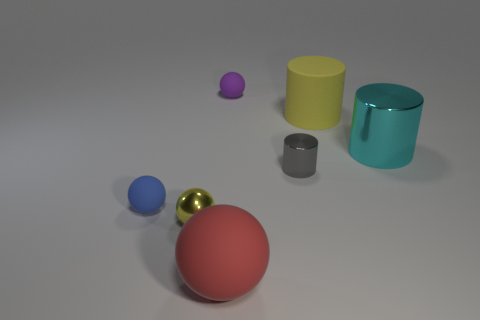What size is the sphere that is to the right of the small yellow shiny ball and in front of the blue object?
Your response must be concise. Large. The large matte thing that is the same shape as the small blue object is what color?
Your response must be concise. Red. Is the number of yellow metallic spheres on the left side of the small yellow thing greater than the number of large yellow rubber things in front of the large cyan metallic cylinder?
Your response must be concise. No. What number of other things are there of the same shape as the small blue object?
Your answer should be compact. 3. Is there a gray metallic cylinder on the left side of the yellow thing behind the tiny blue matte ball?
Provide a succinct answer. Yes. What number of things are there?
Make the answer very short. 7. There is a big shiny cylinder; does it have the same color as the rubber sphere that is to the left of the small yellow metal sphere?
Make the answer very short. No. Are there more cyan metal blocks than blue rubber spheres?
Provide a succinct answer. No. Are there any other things that are the same color as the large shiny cylinder?
Offer a terse response. No. What number of other objects are the same size as the blue sphere?
Your answer should be very brief. 3. 